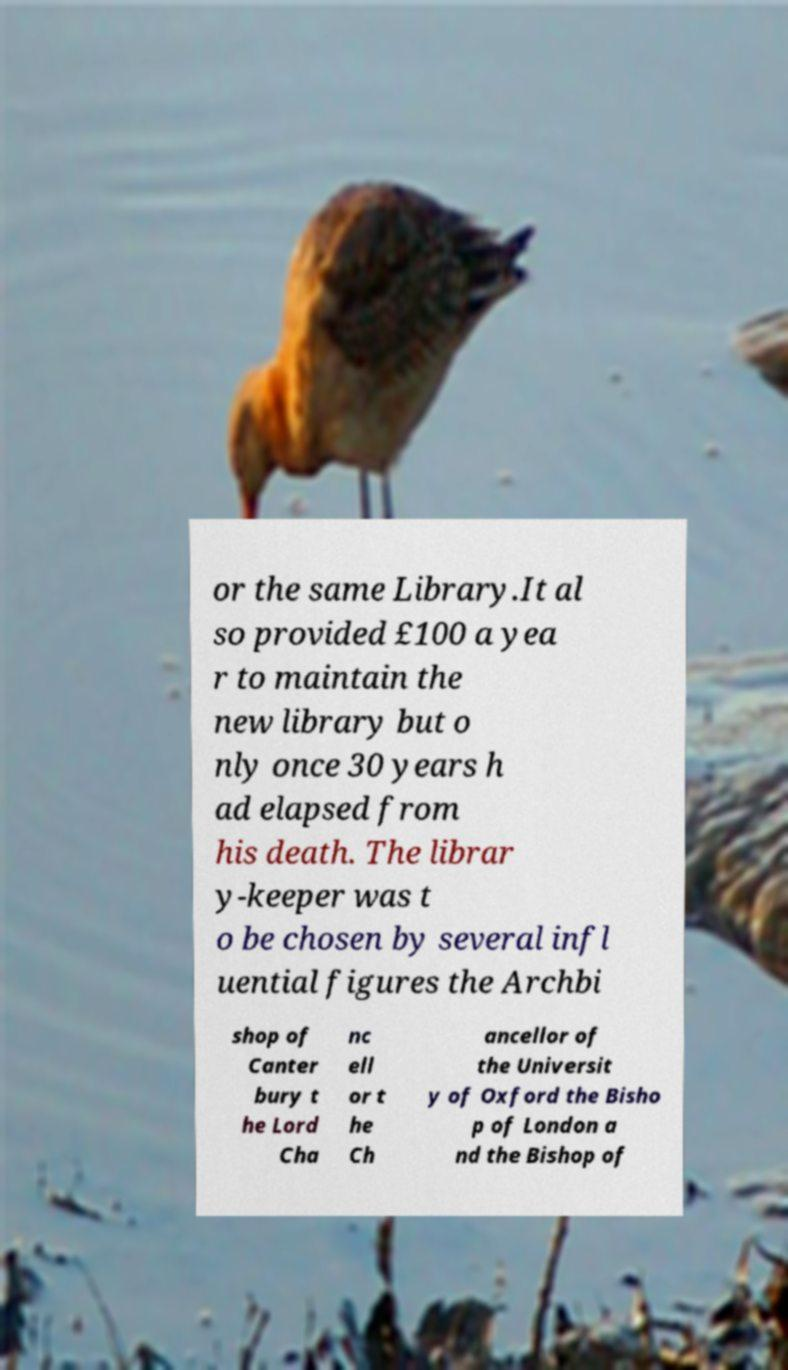Could you extract and type out the text from this image? or the same Library.It al so provided £100 a yea r to maintain the new library but o nly once 30 years h ad elapsed from his death. The librar y-keeper was t o be chosen by several infl uential figures the Archbi shop of Canter bury t he Lord Cha nc ell or t he Ch ancellor of the Universit y of Oxford the Bisho p of London a nd the Bishop of 